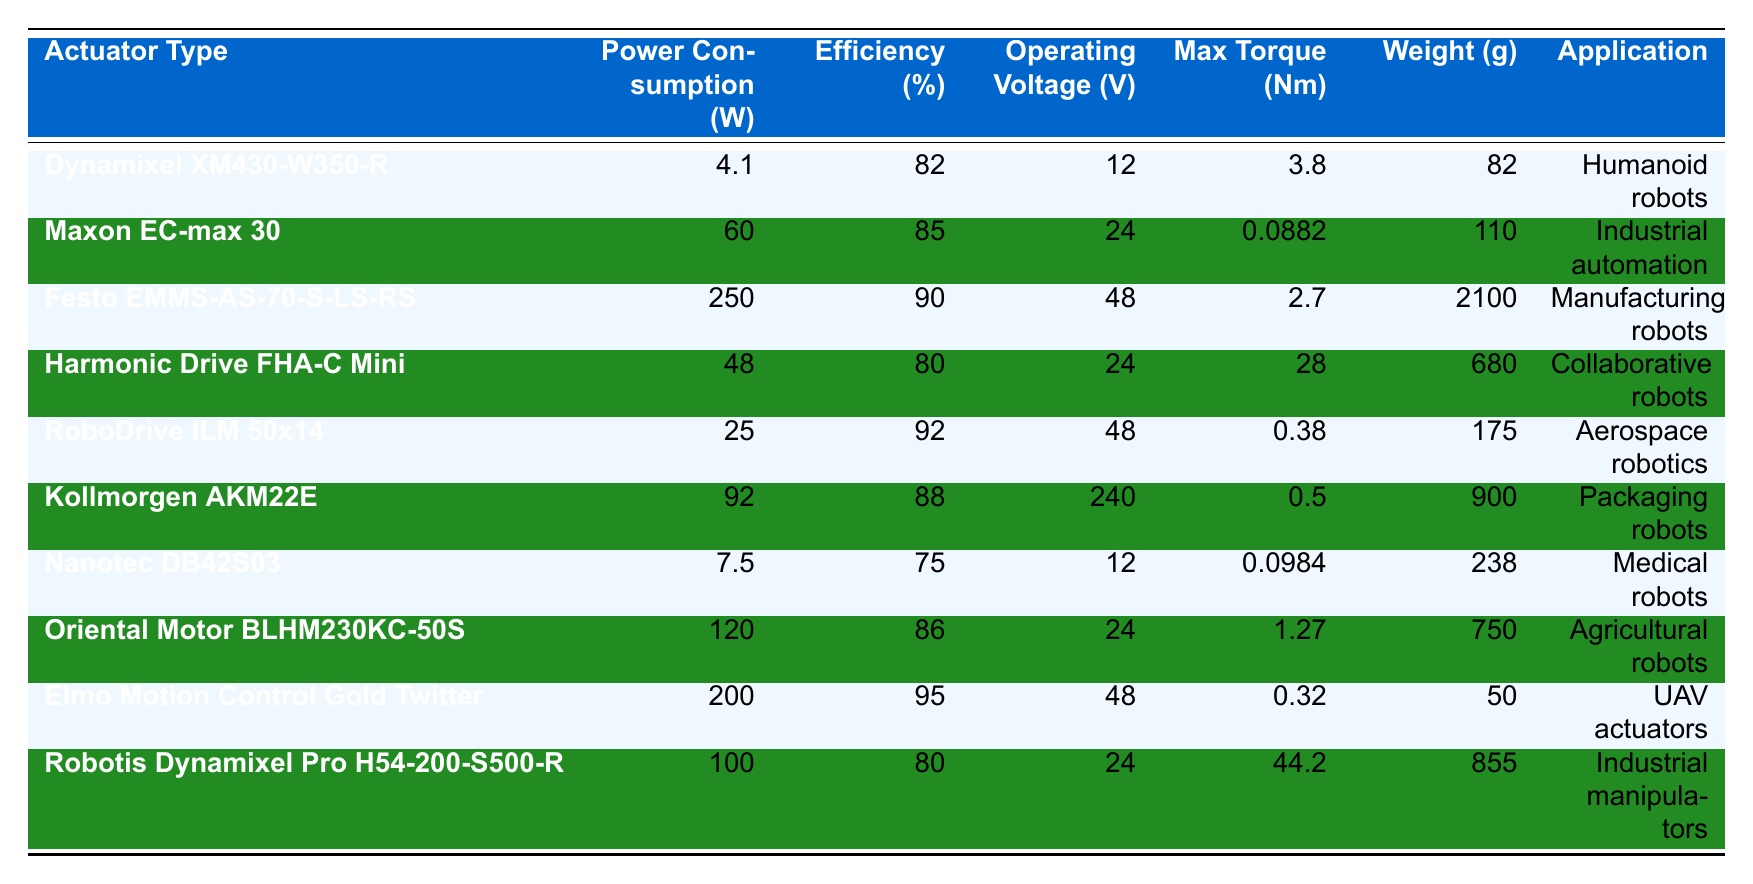What is the power consumption of the Festo EMMS-AS-70-S-LS-RS actuator? The table lists the power consumption for each actuator. For the Festo EMMS-AS-70-S-LS-RS, the power consumption is directly stated in the corresponding row as 250 W.
Answer: 250 W Which actuator has the highest efficiency? To find the highest efficiency, we compare the efficiency percentages listed for each actuator. The maximum value is 95%, found with the Elmo Motion Control Gold Twitter actuator.
Answer: Elmo Motion Control Gold Twitter What is the total weight of all actuators listed? The weights of each actuator are summed together: 82 + 110 + 2100 + 680 + 175 + 900 + 238 + 750 + 50 + 855 = 5080g.
Answer: 5080 g Does the Kollmorgen AKM22E actuator have a higher power consumption than the Dynamixel XM430-W350-R actuator? By comparing the values, Kollmorgen AKM22E has 92 W while Dynamixel XM430-W350-R has only 4.1 W. Therefore, the statement is true.
Answer: Yes What is the average power consumption of the actuators used in agricultural and medical robots? Only two actuators are used in these applications: Oriental Motor BLHM230KC-50S (120 W) and Nanotec DB42S03 (7.5 W). Their average is calculated by (120 + 7.5) / 2 = 63.75 W.
Answer: 63.75 W Which actuator is the lightest and what is its weight? The weights of the actuators are reviewed, and the Nanotec DB42S03 is found to be the lightest at 238 g.
Answer: Nanotec DB42S03, 238 g Is there any actuator that operates at a voltage greater than 240 V? The operating voltages for all actuators are compared, and the maximum value listed is 240 V for the Kollmorgen AKM22E, with no other actuator exceeding this. Thus the answer is no.
Answer: No If we consider only the micro actuators (under 10 W), how many are there? We look through the list for actuators with power consumption below 10 W. The only one fitting this is the Nanotec DB42S03 at 7.5 W. So there is only one micro actuator.
Answer: 1 What is the difference between the maximum torque of the Festo EMMS-AS-70-S-LS-RS and the RoboDrive ILM 50x14? The max torque for Festo EMMS-AS-70-S-LS-RS is 2.7 Nm and for RoboDrive ILM 50x14 it's 0.38 Nm. The difference is 2.7 - 0.38 = 2.32 Nm.
Answer: 2.32 Nm Which actuator has the smallest torque-to-power ratio? The torque-to-power ratio is calculated for each actuator by dividing max torque by power consumption. For the Festo EMMS-AS-70-S-LS-RS, it is calculated as 2.7 / 250 = 0.0108, which is the smallest ratio based on the maximum torque values.
Answer: Festo EMMS-AS-70-S-LS-RS 